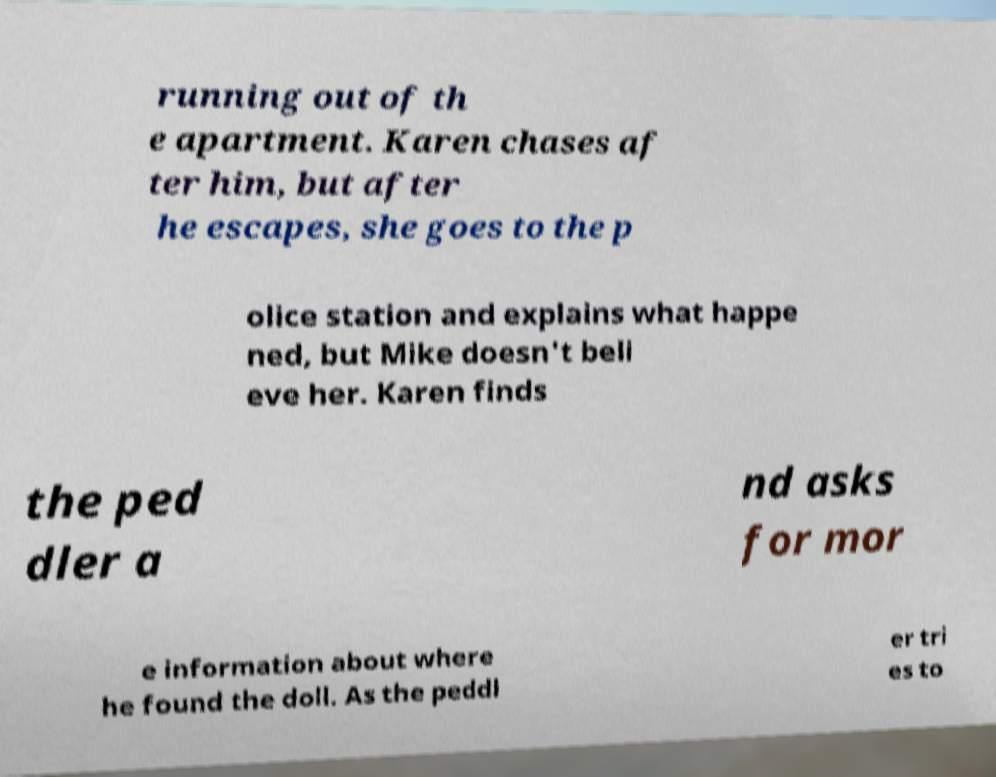I need the written content from this picture converted into text. Can you do that? running out of th e apartment. Karen chases af ter him, but after he escapes, she goes to the p olice station and explains what happe ned, but Mike doesn't beli eve her. Karen finds the ped dler a nd asks for mor e information about where he found the doll. As the peddl er tri es to 